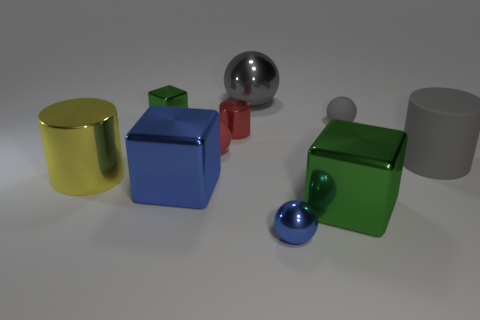Subtract all cylinders. How many objects are left? 7 Add 8 blue metallic objects. How many blue metallic objects are left? 10 Add 8 small blue shiny spheres. How many small blue shiny spheres exist? 9 Subtract 0 yellow spheres. How many objects are left? 10 Subtract all rubber objects. Subtract all large gray metallic cylinders. How many objects are left? 7 